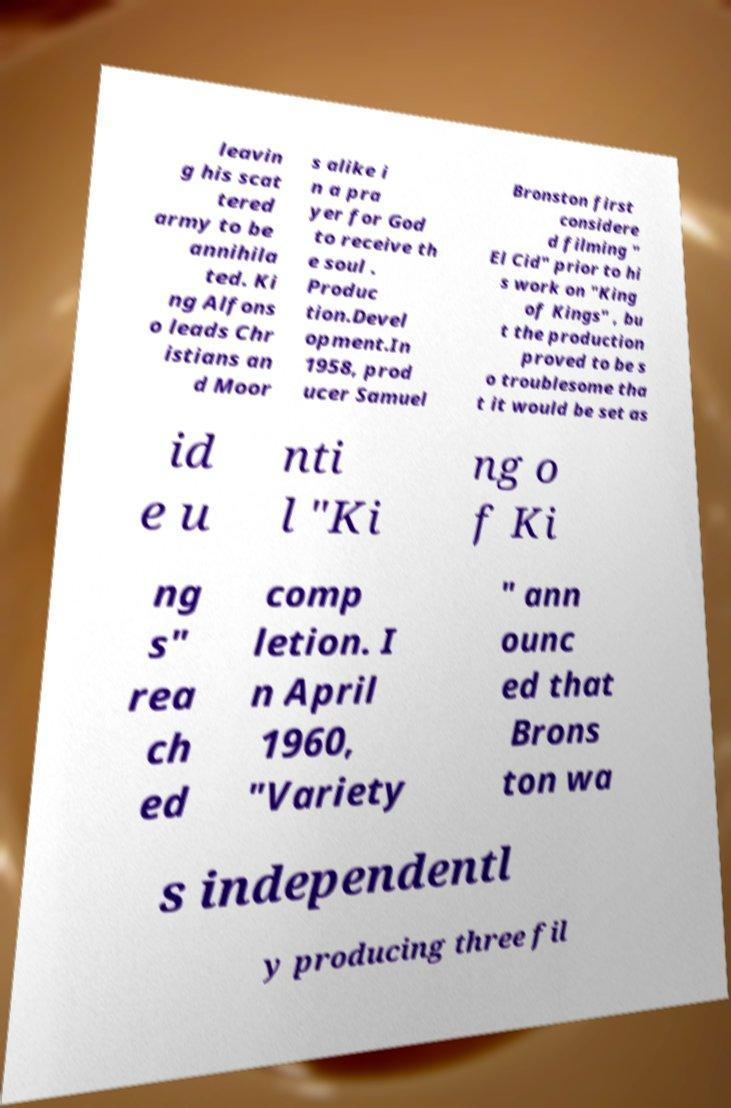There's text embedded in this image that I need extracted. Can you transcribe it verbatim? leavin g his scat tered army to be annihila ted. Ki ng Alfons o leads Chr istians an d Moor s alike i n a pra yer for God to receive th e soul . Produc tion.Devel opment.In 1958, prod ucer Samuel Bronston first considere d filming " El Cid" prior to hi s work on "King of Kings" , bu t the production proved to be s o troublesome tha t it would be set as id e u nti l "Ki ng o f Ki ng s" rea ch ed comp letion. I n April 1960, "Variety " ann ounc ed that Brons ton wa s independentl y producing three fil 